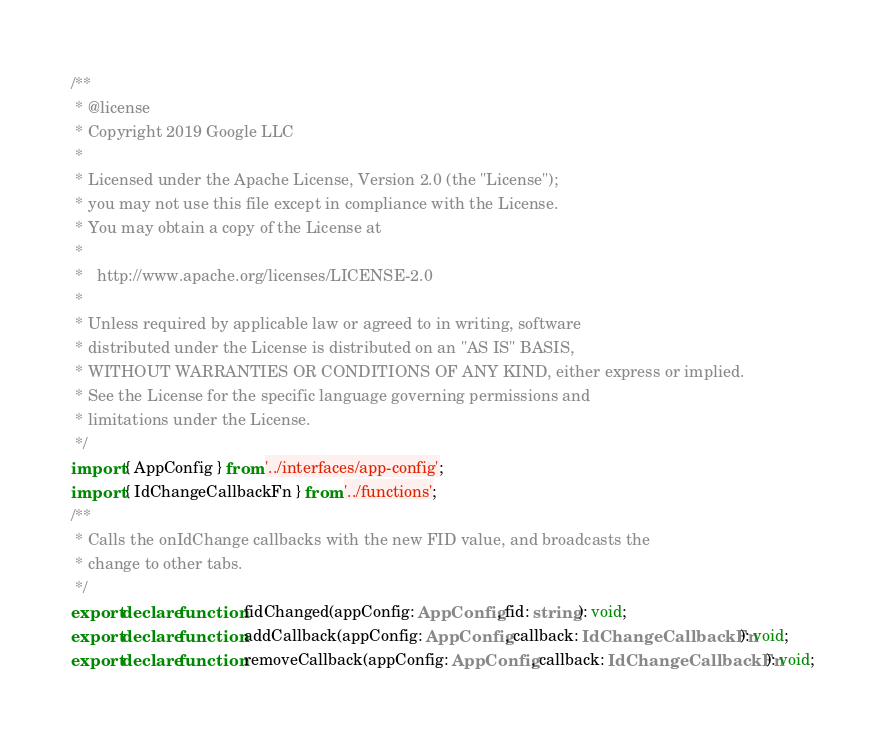Convert code to text. <code><loc_0><loc_0><loc_500><loc_500><_TypeScript_>/**
 * @license
 * Copyright 2019 Google LLC
 *
 * Licensed under the Apache License, Version 2.0 (the "License");
 * you may not use this file except in compliance with the License.
 * You may obtain a copy of the License at
 *
 *   http://www.apache.org/licenses/LICENSE-2.0
 *
 * Unless required by applicable law or agreed to in writing, software
 * distributed under the License is distributed on an "AS IS" BASIS,
 * WITHOUT WARRANTIES OR CONDITIONS OF ANY KIND, either express or implied.
 * See the License for the specific language governing permissions and
 * limitations under the License.
 */
import { AppConfig } from '../interfaces/app-config';
import { IdChangeCallbackFn } from '../functions';
/**
 * Calls the onIdChange callbacks with the new FID value, and broadcasts the
 * change to other tabs.
 */
export declare function fidChanged(appConfig: AppConfig, fid: string): void;
export declare function addCallback(appConfig: AppConfig, callback: IdChangeCallbackFn): void;
export declare function removeCallback(appConfig: AppConfig, callback: IdChangeCallbackFn): void;
</code> 